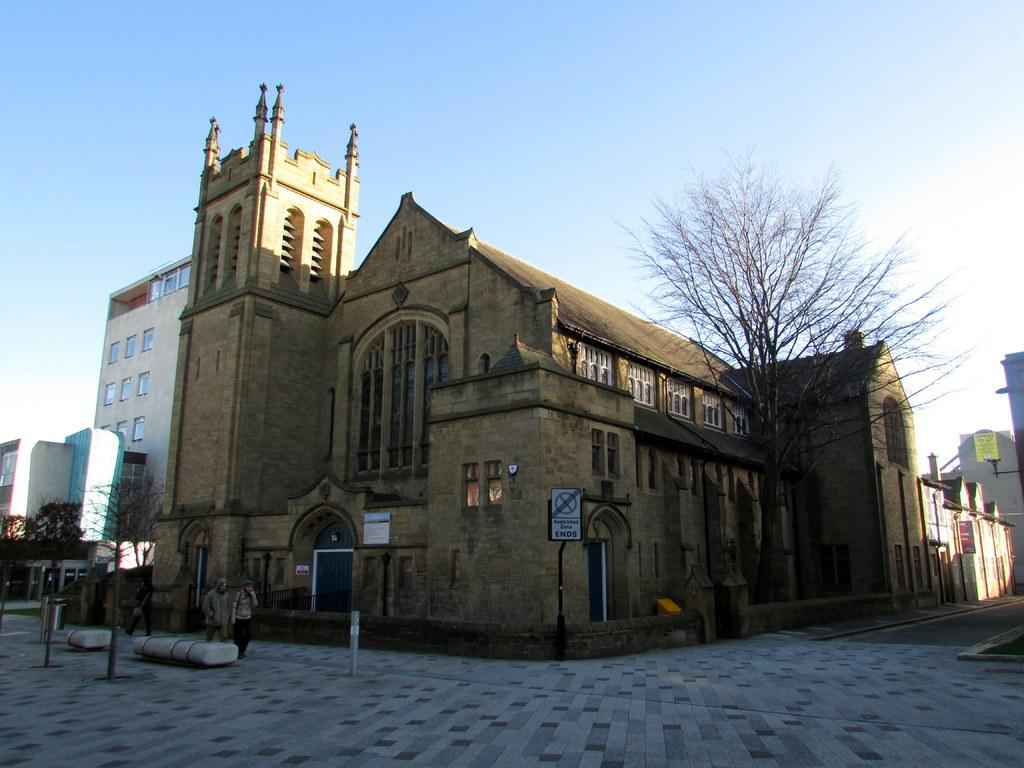What is the main structure in the middle of the image? There is a big house in the middle of the image. What are the two persons in the image doing? The two persons are walking on the footpath on the left side of the image. What type of vegetation is on the right side of the image? There is a tree on the right side of the image. What is visible at the top of the image? The sky is visible at the top of the image. Can you tell me how many grapes are hanging from the tree in the image? There are no grapes present in the image; it features a tree without any visible fruits. What part of the brain is visible in the image? There is no brain present in the image; it is a photograph of a house, people, and a tree. 